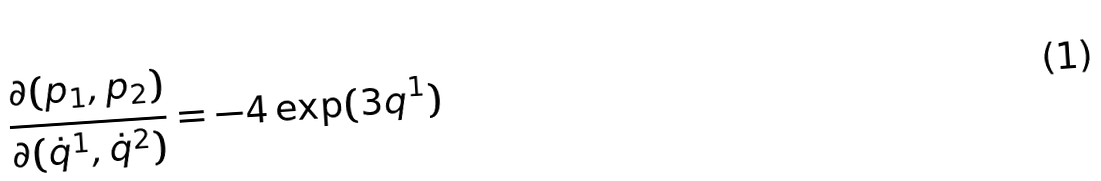<formula> <loc_0><loc_0><loc_500><loc_500>\frac { \partial ( p _ { 1 } , p _ { 2 } ) } { \partial ( \dot { q } ^ { 1 } , \dot { q } ^ { 2 } ) } = - 4 \exp ( 3 q ^ { 1 } )</formula> 